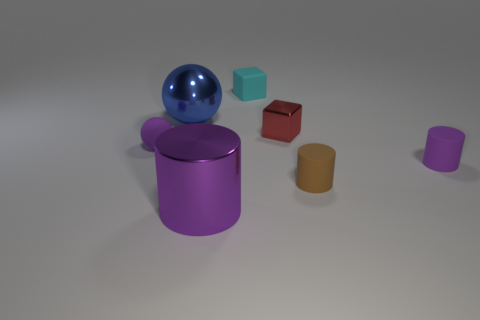There is a small sphere that is the same color as the large shiny cylinder; what material is it?
Ensure brevity in your answer.  Rubber. There is a purple matte thing in front of the purple thing that is on the left side of the large purple cylinder; are there any large balls in front of it?
Ensure brevity in your answer.  No. Are there fewer tiny cyan things in front of the big blue metal sphere than purple matte cylinders on the left side of the cyan rubber block?
Your response must be concise. No. What color is the cube that is made of the same material as the big blue ball?
Make the answer very short. Red. What is the color of the large shiny thing in front of the tiny block that is right of the cyan matte cube?
Ensure brevity in your answer.  Purple. Is there another big metallic cylinder of the same color as the shiny cylinder?
Provide a short and direct response. No. There is a shiny object that is the same size as the brown cylinder; what is its shape?
Make the answer very short. Cube. How many balls are in front of the cube to the right of the cyan thing?
Your response must be concise. 1. Is the big cylinder the same color as the matte sphere?
Make the answer very short. Yes. How many other things are there of the same material as the large blue object?
Provide a succinct answer. 2. 